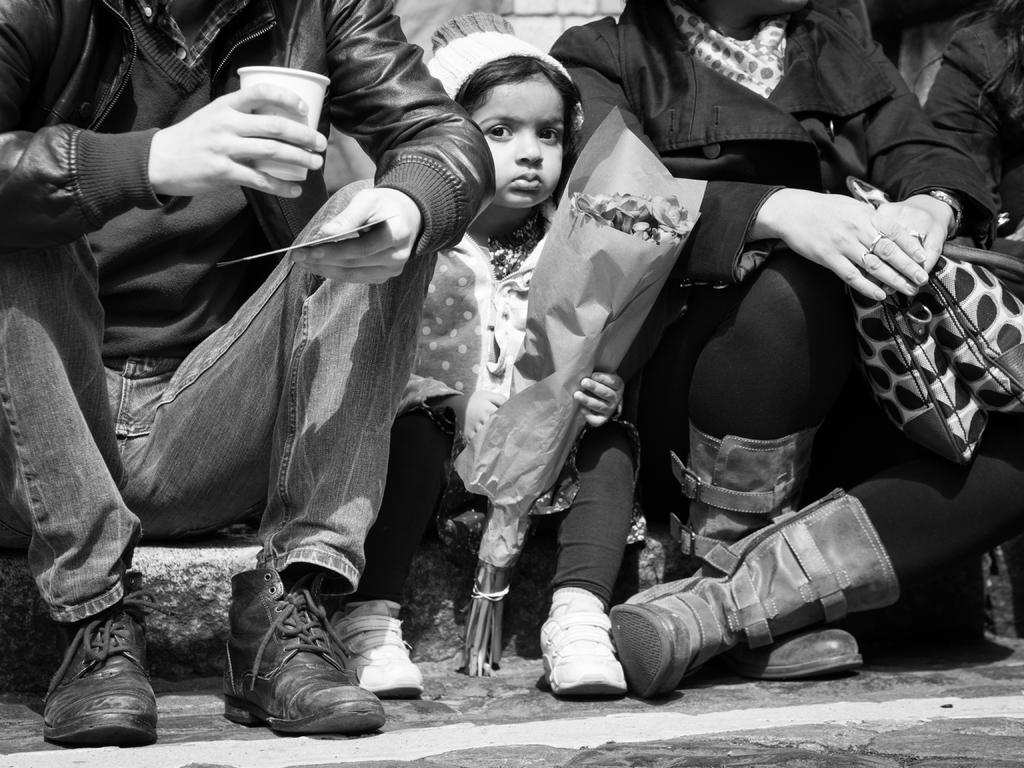What is the kid in the image doing? The kid is sitting in the image. What is the kid holding? The kid is holding a flower bouquet. How many people are sitting in the image? There are two persons sitting in the image. What is one person holding? One person is holding a cup. What is the other person holding? The other person is holding a bag. Can you tell me what type of eggnog is being served in the image? There is no eggnog present in the image. Is there a railway visible in the image? There is no railway visible in the image. 